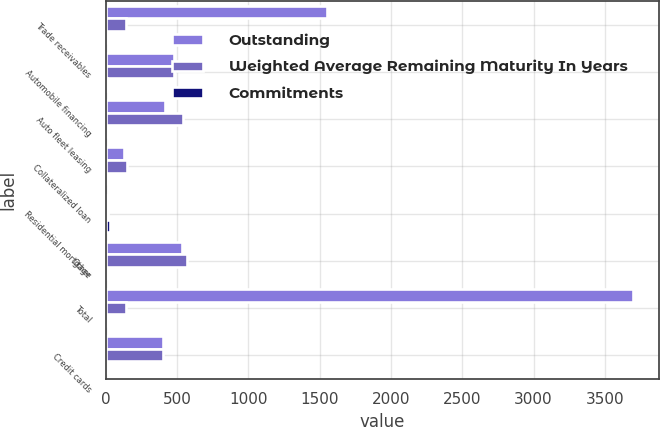Convert chart. <chart><loc_0><loc_0><loc_500><loc_500><stacked_bar_chart><ecel><fcel>Trade receivables<fcel>Automobile financing<fcel>Auto fleet leasing<fcel>Collateralized loan<fcel>Residential mortgage<fcel>Other<fcel>Total<fcel>Credit cards<nl><fcel>Outstanding<fcel>1551<fcel>480<fcel>412<fcel>126<fcel>13<fcel>534<fcel>3698<fcel>400<nl><fcel>Weighted Average Remaining Maturity In Years<fcel>138<fcel>480<fcel>543<fcel>150<fcel>13<fcel>567<fcel>138<fcel>400<nl><fcel>Commitments<fcel>2.01<fcel>4.2<fcel>0.85<fcel>0.36<fcel>26.01<fcel>1.65<fcel>2.06<fcel>0.19<nl></chart> 